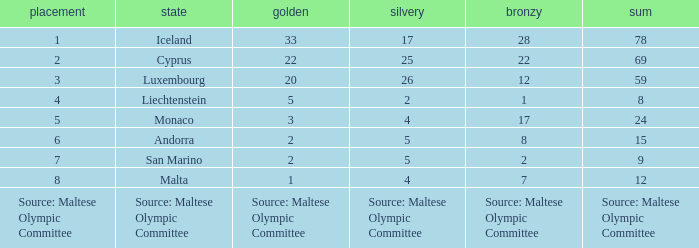How many bronze medals does the nation ranked number 1 have? 28.0. 